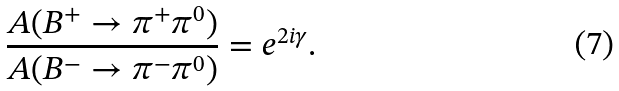Convert formula to latex. <formula><loc_0><loc_0><loc_500><loc_500>\frac { A ( B ^ { + } \to \pi ^ { + } \pi ^ { 0 } ) } { A ( B ^ { - } \to \pi ^ { - } \pi ^ { 0 } ) } = e ^ { 2 i \gamma } .</formula> 